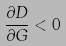<formula> <loc_0><loc_0><loc_500><loc_500>\frac { \partial D } { \partial G } < 0</formula> 